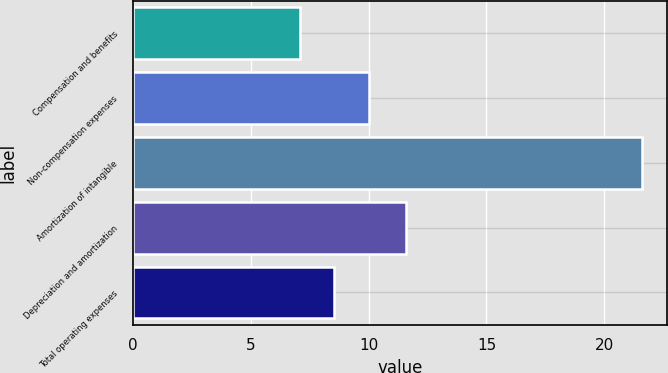<chart> <loc_0><loc_0><loc_500><loc_500><bar_chart><fcel>Compensation and benefits<fcel>Non-compensation expenses<fcel>Amortization of intangible<fcel>Depreciation and amortization<fcel>Total operating expenses<nl><fcel>7.1<fcel>10<fcel>21.6<fcel>11.6<fcel>8.55<nl></chart> 